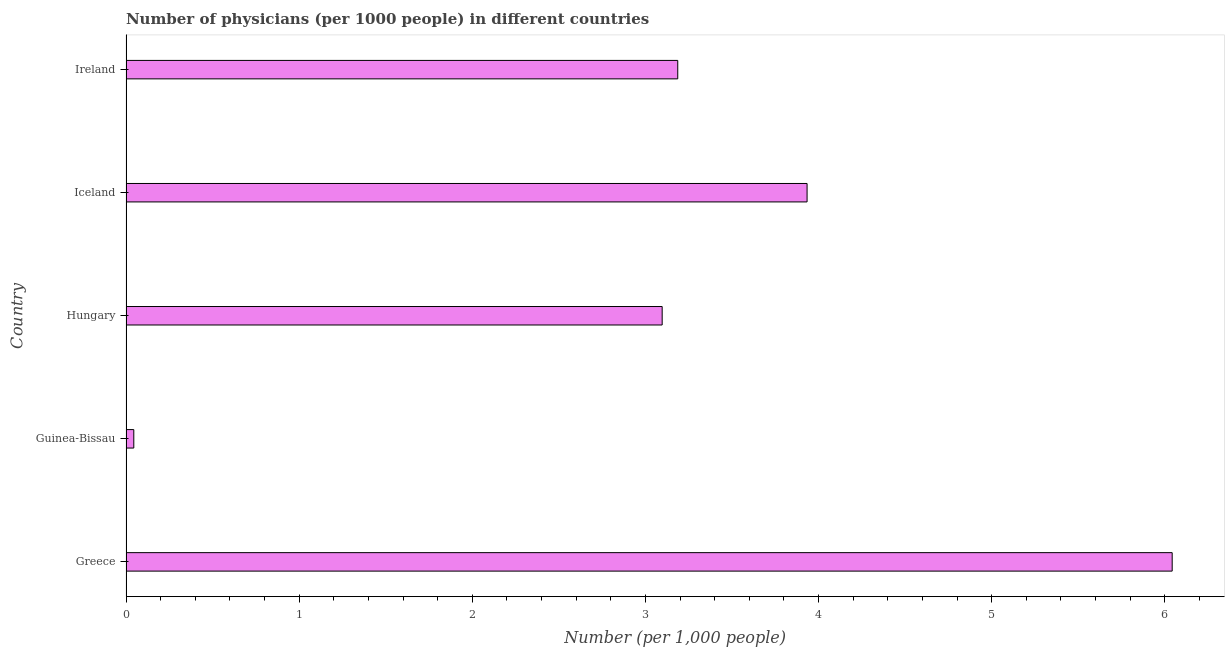Does the graph contain any zero values?
Your answer should be very brief. No. Does the graph contain grids?
Offer a terse response. No. What is the title of the graph?
Ensure brevity in your answer.  Number of physicians (per 1000 people) in different countries. What is the label or title of the X-axis?
Offer a terse response. Number (per 1,0 people). What is the number of physicians in Guinea-Bissau?
Provide a short and direct response. 0.04. Across all countries, what is the maximum number of physicians?
Your answer should be compact. 6.04. Across all countries, what is the minimum number of physicians?
Ensure brevity in your answer.  0.04. In which country was the number of physicians minimum?
Your response must be concise. Guinea-Bissau. What is the sum of the number of physicians?
Offer a very short reply. 16.31. What is the difference between the number of physicians in Iceland and Ireland?
Your response must be concise. 0.75. What is the average number of physicians per country?
Provide a short and direct response. 3.26. What is the median number of physicians?
Make the answer very short. 3.19. In how many countries, is the number of physicians greater than 0.4 ?
Provide a short and direct response. 4. What is the ratio of the number of physicians in Guinea-Bissau to that in Ireland?
Your response must be concise. 0.01. Is the number of physicians in Guinea-Bissau less than that in Ireland?
Make the answer very short. Yes. What is the difference between the highest and the second highest number of physicians?
Keep it short and to the point. 2.11. Is the sum of the number of physicians in Guinea-Bissau and Hungary greater than the maximum number of physicians across all countries?
Ensure brevity in your answer.  No. What is the difference between the highest and the lowest number of physicians?
Provide a short and direct response. 6. In how many countries, is the number of physicians greater than the average number of physicians taken over all countries?
Your answer should be compact. 2. How many countries are there in the graph?
Provide a succinct answer. 5. What is the difference between two consecutive major ticks on the X-axis?
Your answer should be compact. 1. What is the Number (per 1,000 people) in Greece?
Make the answer very short. 6.04. What is the Number (per 1,000 people) in Guinea-Bissau?
Keep it short and to the point. 0.04. What is the Number (per 1,000 people) of Hungary?
Give a very brief answer. 3.1. What is the Number (per 1,000 people) in Iceland?
Provide a short and direct response. 3.93. What is the Number (per 1,000 people) of Ireland?
Make the answer very short. 3.19. What is the difference between the Number (per 1,000 people) in Greece and Guinea-Bissau?
Your answer should be very brief. 6. What is the difference between the Number (per 1,000 people) in Greece and Hungary?
Make the answer very short. 2.95. What is the difference between the Number (per 1,000 people) in Greece and Iceland?
Offer a terse response. 2.11. What is the difference between the Number (per 1,000 people) in Greece and Ireland?
Provide a short and direct response. 2.86. What is the difference between the Number (per 1,000 people) in Guinea-Bissau and Hungary?
Offer a very short reply. -3.05. What is the difference between the Number (per 1,000 people) in Guinea-Bissau and Iceland?
Offer a terse response. -3.89. What is the difference between the Number (per 1,000 people) in Guinea-Bissau and Ireland?
Your response must be concise. -3.14. What is the difference between the Number (per 1,000 people) in Hungary and Iceland?
Provide a succinct answer. -0.84. What is the difference between the Number (per 1,000 people) in Hungary and Ireland?
Your answer should be very brief. -0.09. What is the difference between the Number (per 1,000 people) in Iceland and Ireland?
Your answer should be very brief. 0.75. What is the ratio of the Number (per 1,000 people) in Greece to that in Guinea-Bissau?
Your answer should be compact. 134.29. What is the ratio of the Number (per 1,000 people) in Greece to that in Hungary?
Give a very brief answer. 1.95. What is the ratio of the Number (per 1,000 people) in Greece to that in Iceland?
Give a very brief answer. 1.54. What is the ratio of the Number (per 1,000 people) in Greece to that in Ireland?
Make the answer very short. 1.9. What is the ratio of the Number (per 1,000 people) in Guinea-Bissau to that in Hungary?
Offer a terse response. 0.01. What is the ratio of the Number (per 1,000 people) in Guinea-Bissau to that in Iceland?
Ensure brevity in your answer.  0.01. What is the ratio of the Number (per 1,000 people) in Guinea-Bissau to that in Ireland?
Give a very brief answer. 0.01. What is the ratio of the Number (per 1,000 people) in Hungary to that in Iceland?
Your answer should be very brief. 0.79. What is the ratio of the Number (per 1,000 people) in Iceland to that in Ireland?
Provide a succinct answer. 1.23. 